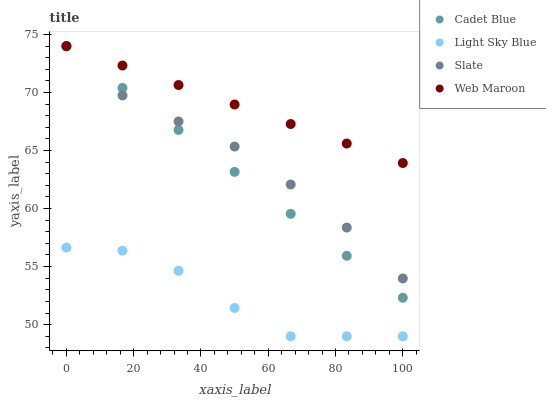Does Light Sky Blue have the minimum area under the curve?
Answer yes or no. Yes. Does Web Maroon have the maximum area under the curve?
Answer yes or no. Yes. Does Cadet Blue have the minimum area under the curve?
Answer yes or no. No. Does Cadet Blue have the maximum area under the curve?
Answer yes or no. No. Is Web Maroon the smoothest?
Answer yes or no. Yes. Is Light Sky Blue the roughest?
Answer yes or no. Yes. Is Cadet Blue the smoothest?
Answer yes or no. No. Is Cadet Blue the roughest?
Answer yes or no. No. Does Light Sky Blue have the lowest value?
Answer yes or no. Yes. Does Cadet Blue have the lowest value?
Answer yes or no. No. Does Web Maroon have the highest value?
Answer yes or no. Yes. Does Light Sky Blue have the highest value?
Answer yes or no. No. Is Slate less than Web Maroon?
Answer yes or no. Yes. Is Slate greater than Light Sky Blue?
Answer yes or no. Yes. Does Web Maroon intersect Cadet Blue?
Answer yes or no. Yes. Is Web Maroon less than Cadet Blue?
Answer yes or no. No. Is Web Maroon greater than Cadet Blue?
Answer yes or no. No. Does Slate intersect Web Maroon?
Answer yes or no. No. 